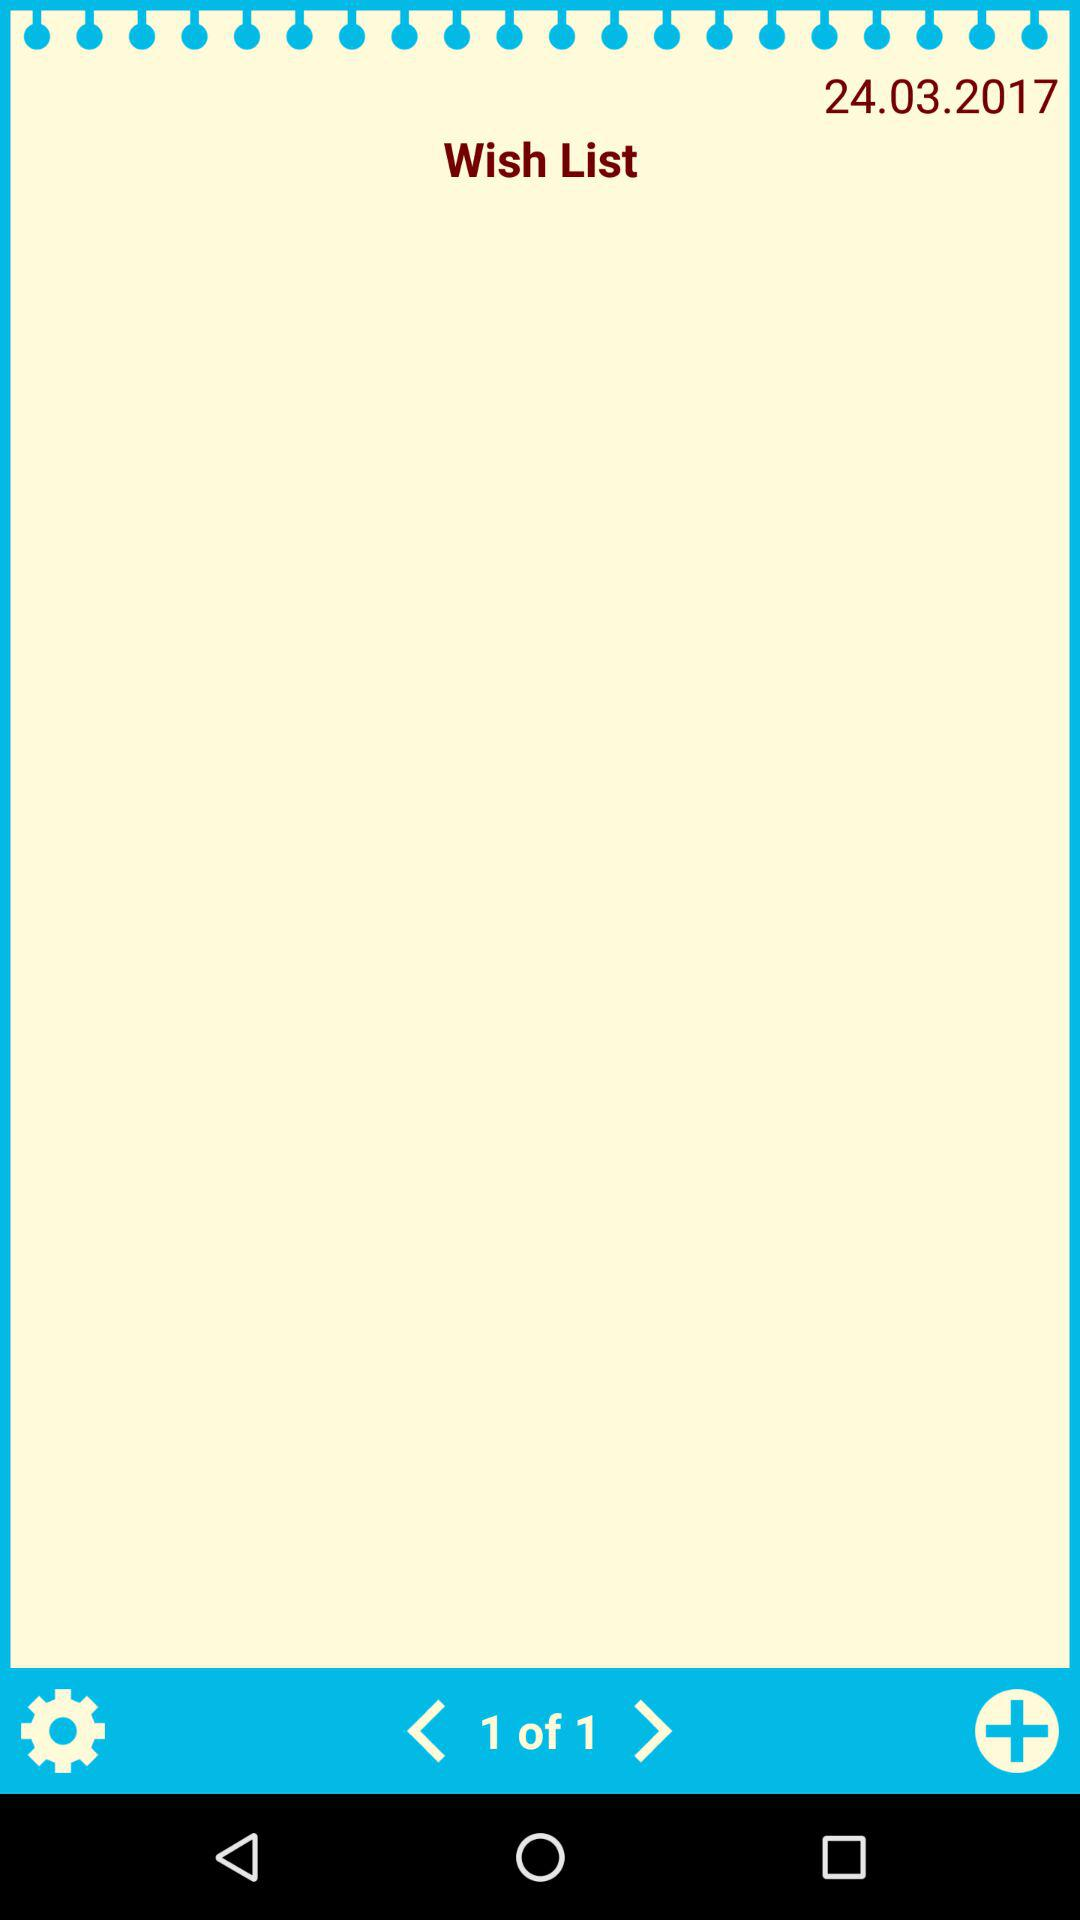On what page are we currently? You are currently on page number 1. 